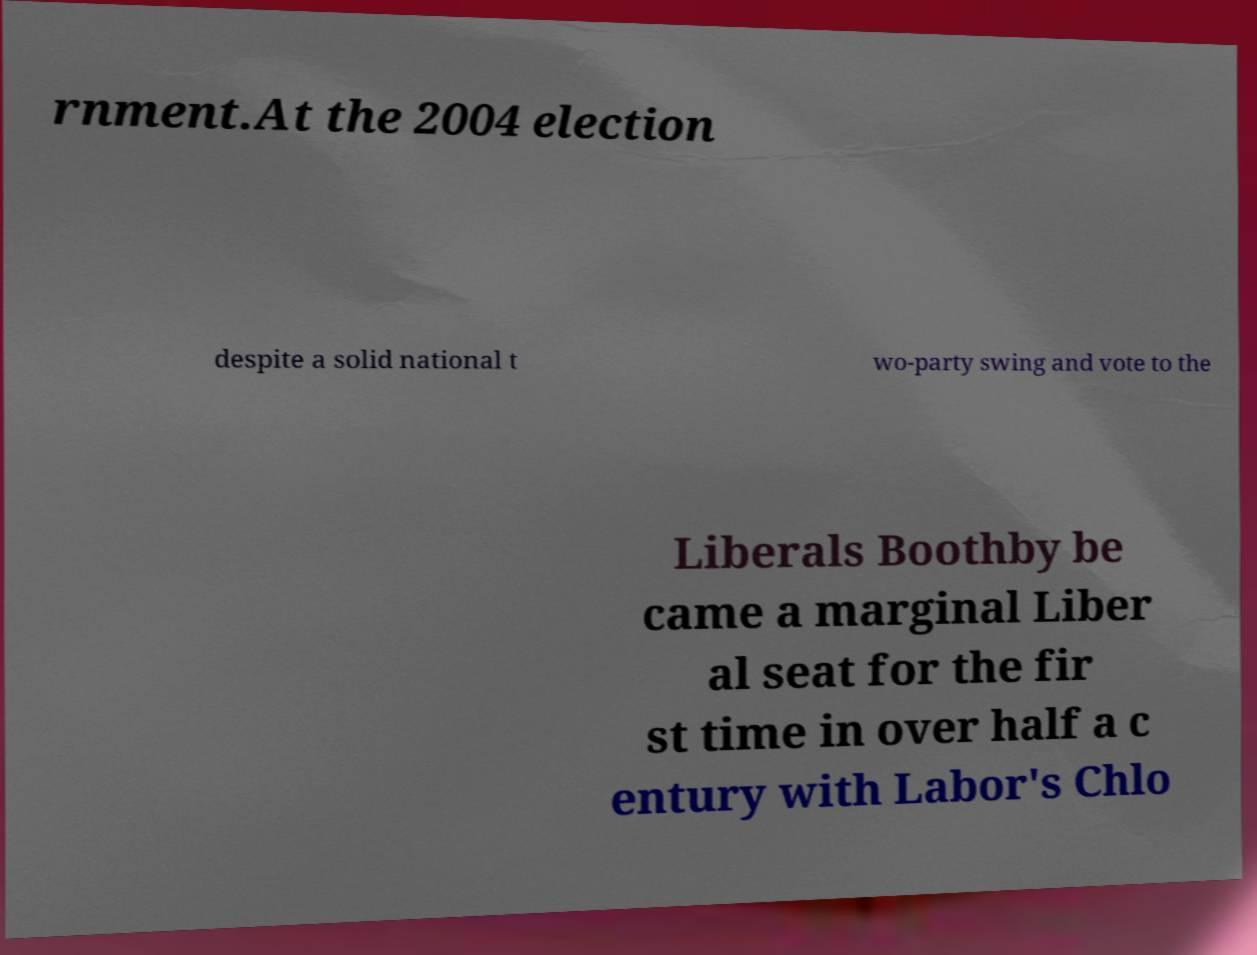Can you read and provide the text displayed in the image?This photo seems to have some interesting text. Can you extract and type it out for me? rnment.At the 2004 election despite a solid national t wo-party swing and vote to the Liberals Boothby be came a marginal Liber al seat for the fir st time in over half a c entury with Labor's Chlo 